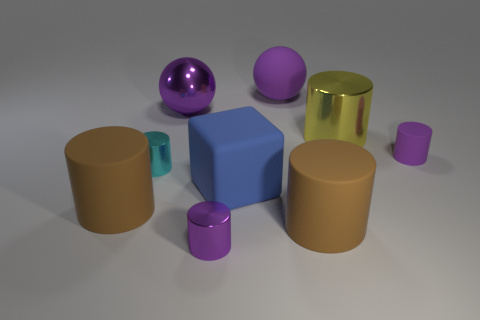Subtract all brown cylinders. How many were subtracted if there are1brown cylinders left? 1 Subtract all yellow cubes. How many purple cylinders are left? 2 Subtract all tiny rubber cylinders. How many cylinders are left? 5 Subtract all brown cylinders. How many cylinders are left? 4 Add 1 brown matte things. How many objects exist? 10 Subtract 3 cylinders. How many cylinders are left? 3 Subtract all yellow spheres. Subtract all blue blocks. How many spheres are left? 2 Subtract all cyan things. Subtract all large matte blocks. How many objects are left? 7 Add 9 small purple matte cylinders. How many small purple matte cylinders are left? 10 Add 4 large rubber balls. How many large rubber balls exist? 5 